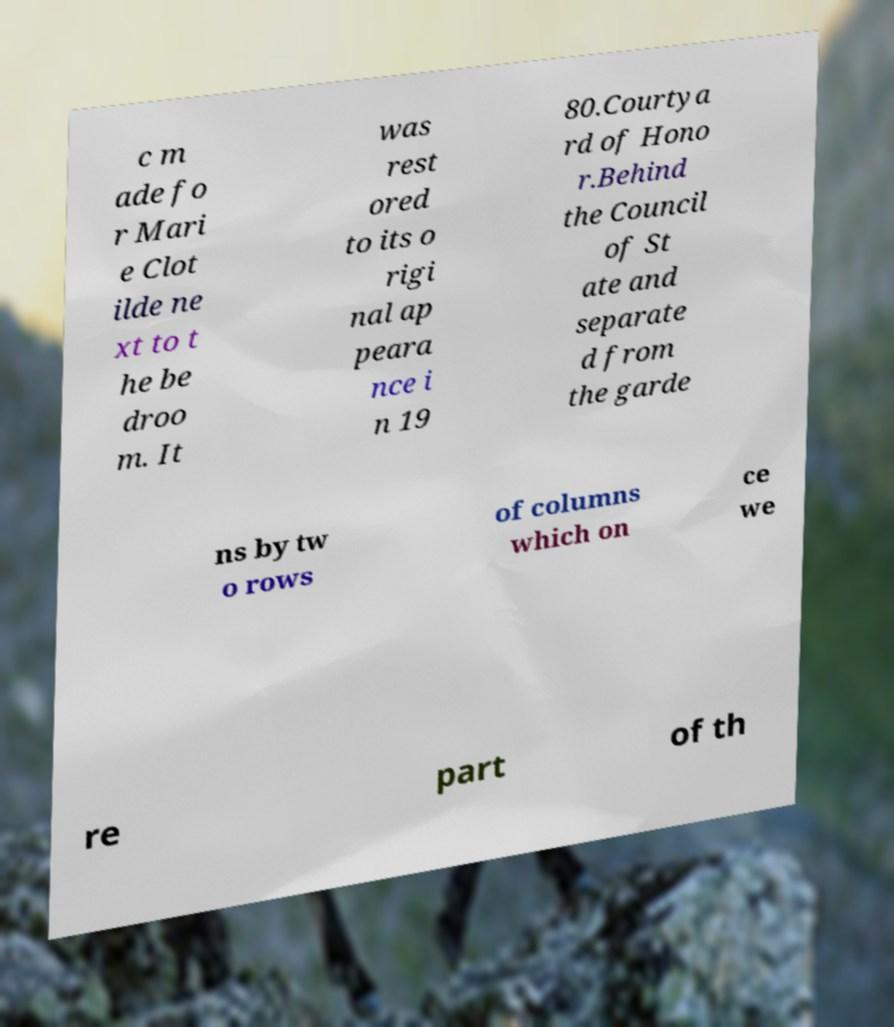There's text embedded in this image that I need extracted. Can you transcribe it verbatim? c m ade fo r Mari e Clot ilde ne xt to t he be droo m. It was rest ored to its o rigi nal ap peara nce i n 19 80.Courtya rd of Hono r.Behind the Council of St ate and separate d from the garde ns by tw o rows of columns which on ce we re part of th 